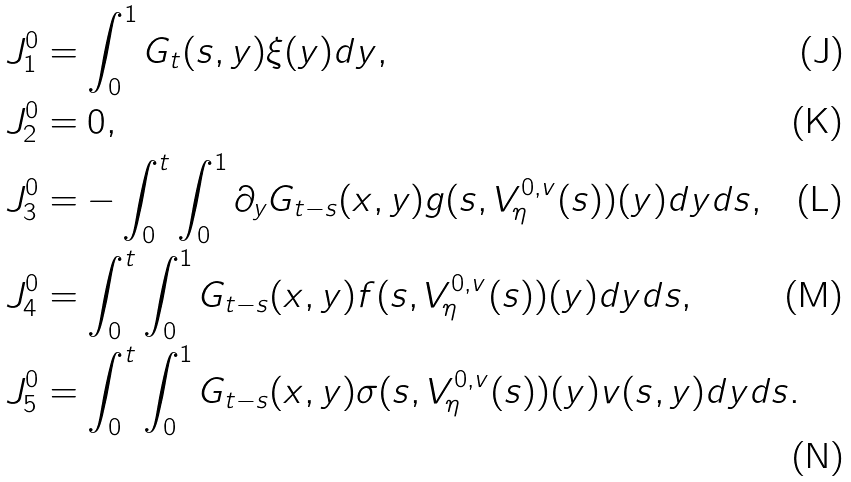<formula> <loc_0><loc_0><loc_500><loc_500>& J _ { 1 } ^ { 0 } = \int _ { 0 } ^ { 1 } G _ { t } ( s , y ) \xi ( y ) d y , \\ & J _ { 2 } ^ { 0 } = 0 , \\ & J _ { 3 } ^ { 0 } = - \int _ { 0 } ^ { t } \int _ { 0 } ^ { 1 } \partial _ { y } G _ { t - s } ( x , y ) g ( s , V ^ { { 0 } , v } _ { \eta } ( s ) ) ( y ) d y d s , \\ & J _ { 4 } ^ { 0 } = \int _ { 0 } ^ { t } \int _ { 0 } ^ { 1 } G _ { t - s } ( x , y ) f ( s , V ^ { { 0 } , v } _ { \eta } ( s ) ) ( y ) d y d s , \\ & J _ { 5 } ^ { 0 } = \int _ { 0 } ^ { t } \int _ { 0 } ^ { 1 } G _ { t - s } ( x , y ) \sigma ( s , V ^ { { 0 } , v } _ { \eta } ( s ) ) ( y ) v ( s , y ) d y d s .</formula> 